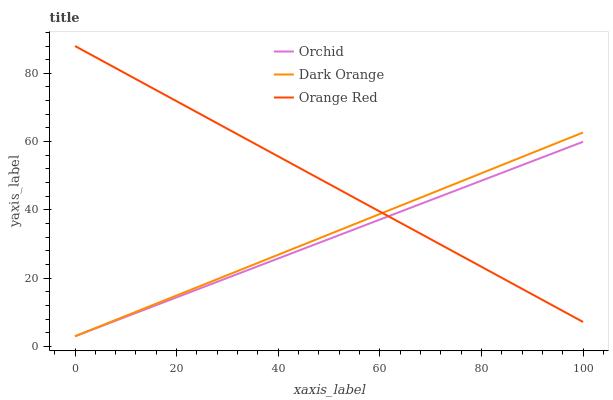Does Orchid have the minimum area under the curve?
Answer yes or no. Yes. Does Orange Red have the maximum area under the curve?
Answer yes or no. Yes. Does Orange Red have the minimum area under the curve?
Answer yes or no. No. Does Orchid have the maximum area under the curve?
Answer yes or no. No. Is Dark Orange the smoothest?
Answer yes or no. Yes. Is Orange Red the roughest?
Answer yes or no. Yes. Is Orchid the smoothest?
Answer yes or no. No. Is Orchid the roughest?
Answer yes or no. No. Does Dark Orange have the lowest value?
Answer yes or no. Yes. Does Orange Red have the lowest value?
Answer yes or no. No. Does Orange Red have the highest value?
Answer yes or no. Yes. Does Orchid have the highest value?
Answer yes or no. No. Does Orange Red intersect Orchid?
Answer yes or no. Yes. Is Orange Red less than Orchid?
Answer yes or no. No. Is Orange Red greater than Orchid?
Answer yes or no. No. 